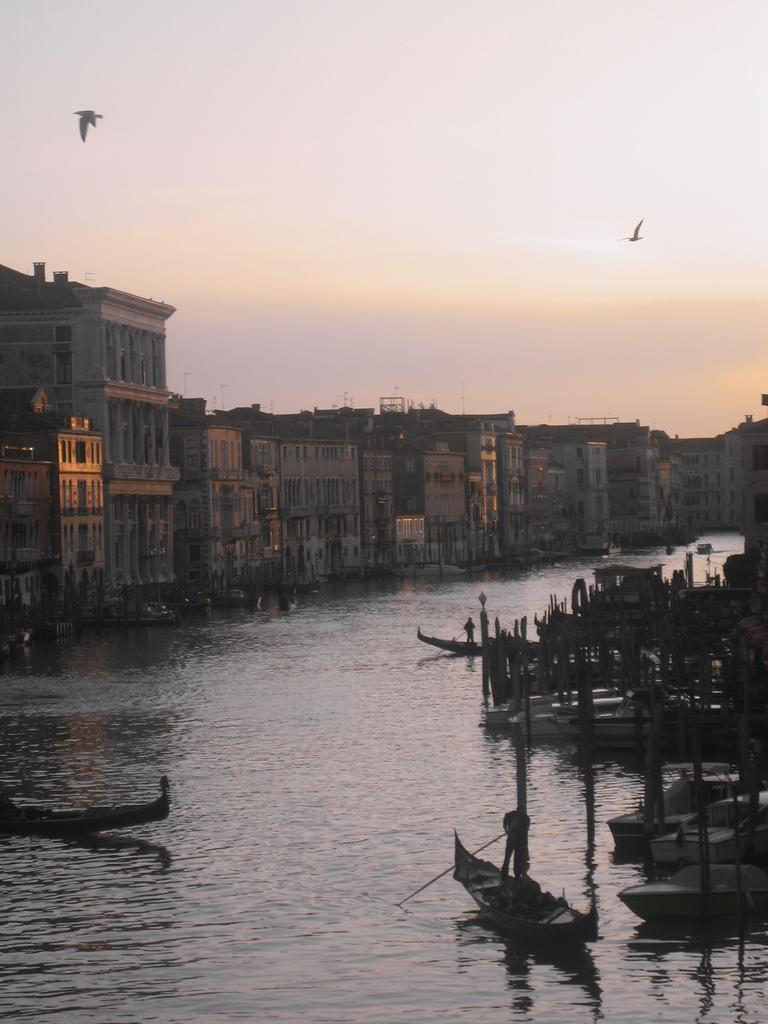Could you give a brief overview of what you see in this image? In this picture I can see the boats on the water. I can see the buildings on the left side. I can see the birds flying. I can see clouds in the sky. 